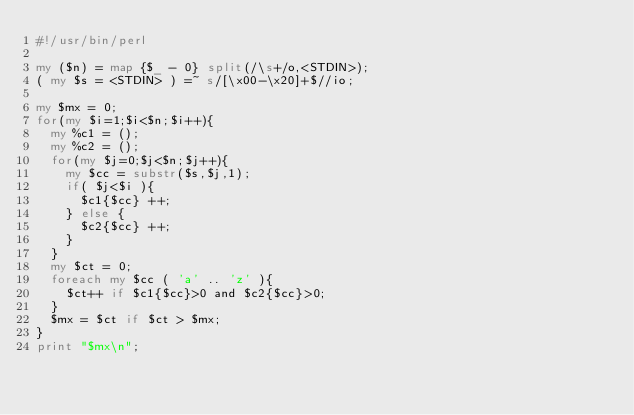<code> <loc_0><loc_0><loc_500><loc_500><_Perl_>#!/usr/bin/perl

my ($n) = map {$_ - 0} split(/\s+/o,<STDIN>);
( my $s = <STDIN> ) =~ s/[\x00-\x20]+$//io;

my $mx = 0;
for(my $i=1;$i<$n;$i++){
  my %c1 = ();
  my %c2 = ();
  for(my $j=0;$j<$n;$j++){
    my $cc = substr($s,$j,1);
    if( $j<$i ){
      $c1{$cc} ++;
    } else {
      $c2{$cc} ++;
    }
  }
  my $ct = 0;
  foreach my $cc ( 'a' .. 'z' ){
    $ct++ if $c1{$cc}>0 and $c2{$cc}>0;
  }
  $mx = $ct if $ct > $mx;
}
print "$mx\n";

</code> 